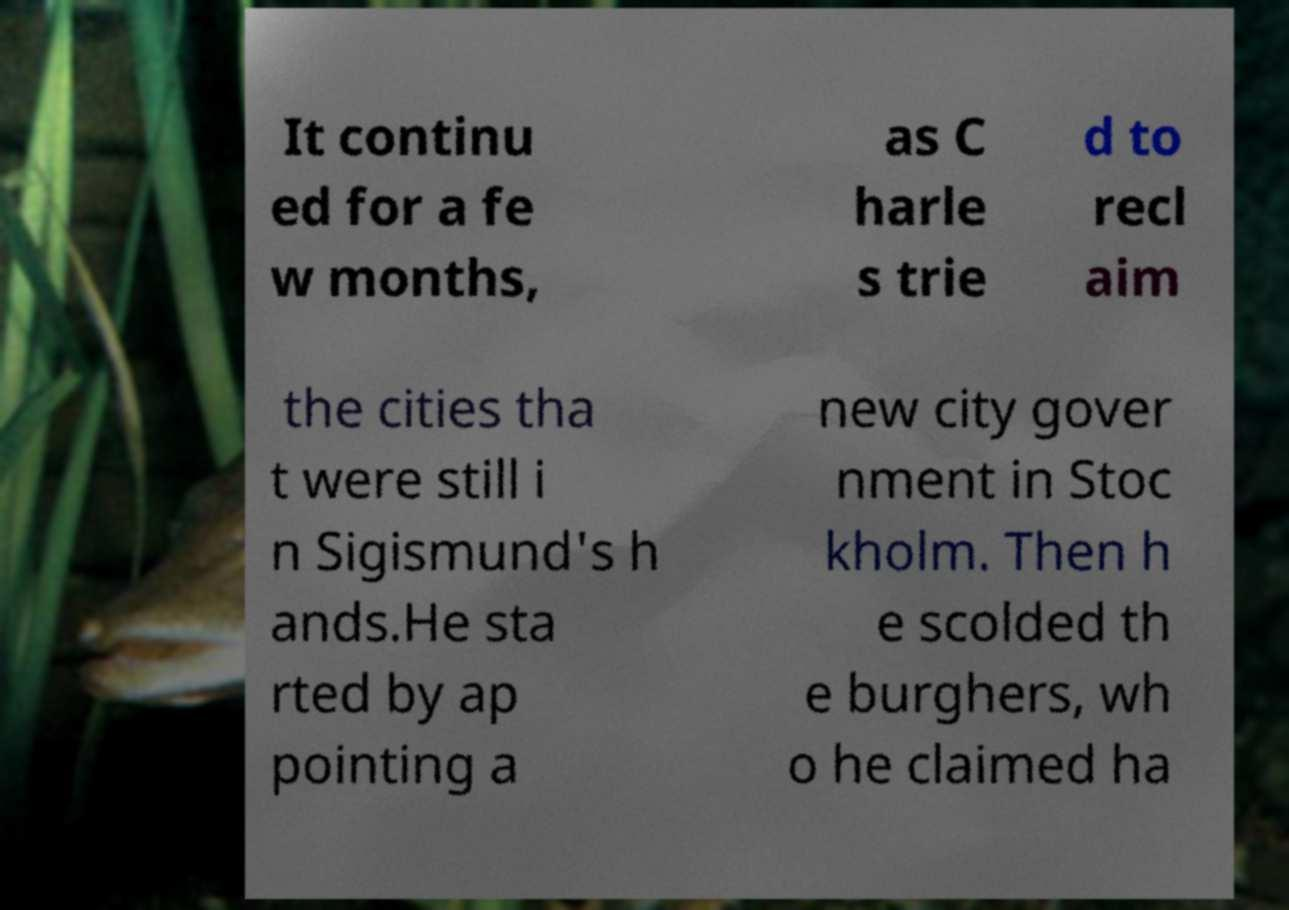Please identify and transcribe the text found in this image. It continu ed for a fe w months, as C harle s trie d to recl aim the cities tha t were still i n Sigismund's h ands.He sta rted by ap pointing a new city gover nment in Stoc kholm. Then h e scolded th e burghers, wh o he claimed ha 